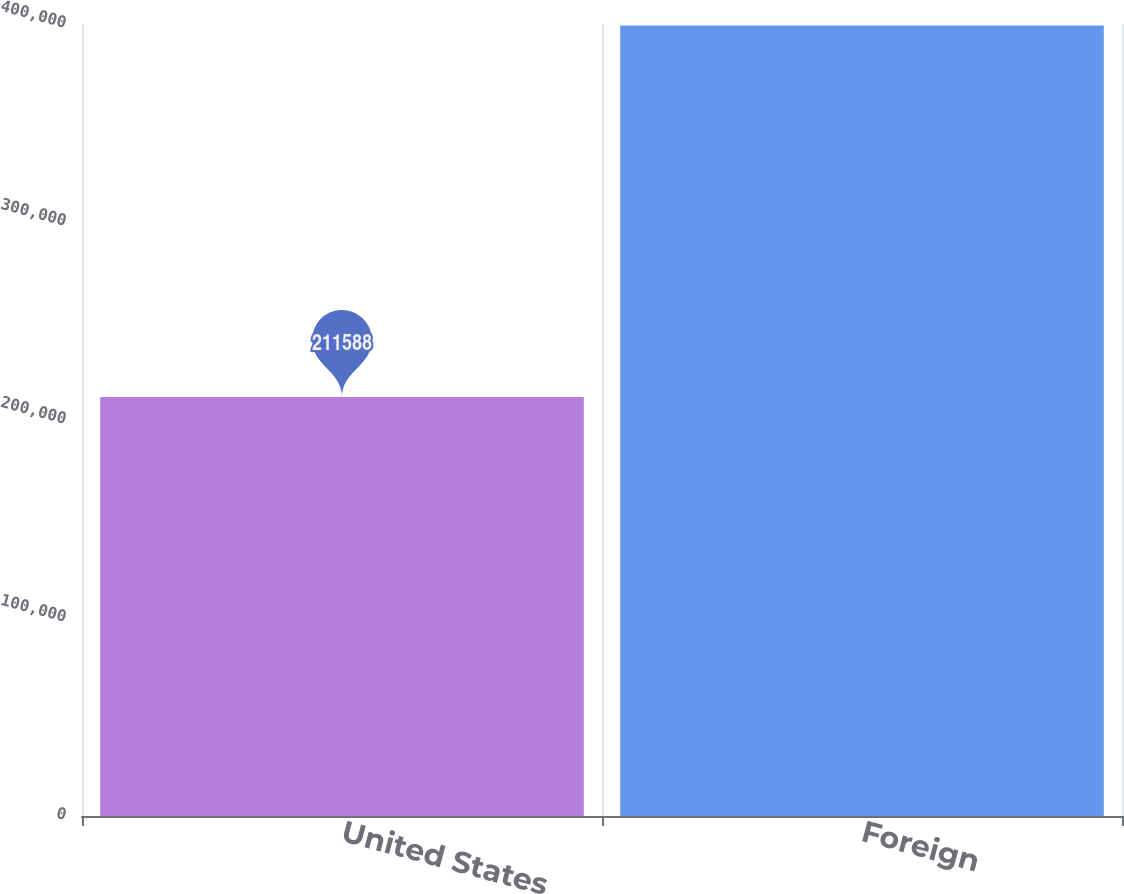Convert chart to OTSL. <chart><loc_0><loc_0><loc_500><loc_500><bar_chart><fcel>United States<fcel>Foreign<nl><fcel>211588<fcel>399301<nl></chart> 